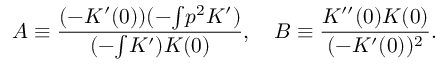<formula> <loc_0><loc_0><loc_500><loc_500>A \equiv \frac { ( - K ^ { \prime } ( 0 ) ) ( - { \int } p ^ { 2 } K ^ { \prime } ) } { ( - { \int } K ^ { \prime } ) K ( 0 ) } , \quad B \equiv \frac { K ^ { \prime \prime } ( 0 ) K ( 0 ) } { ( - K ^ { \prime } ( 0 ) ) ^ { 2 } } .</formula> 